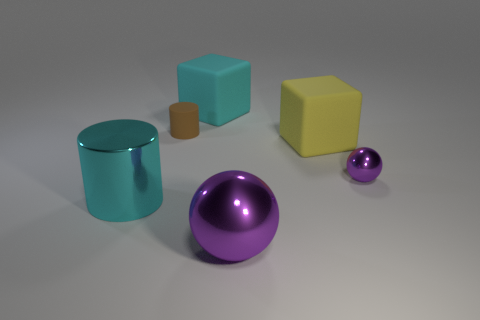Add 2 brown rubber cylinders. How many objects exist? 8 Subtract all cubes. How many objects are left? 4 Add 4 small purple objects. How many small purple objects are left? 5 Add 1 gray rubber objects. How many gray rubber objects exist? 1 Subtract 0 blue spheres. How many objects are left? 6 Subtract all green balls. Subtract all yellow cubes. How many balls are left? 2 Subtract all brown spheres. How many cyan blocks are left? 1 Subtract all small red things. Subtract all brown cylinders. How many objects are left? 5 